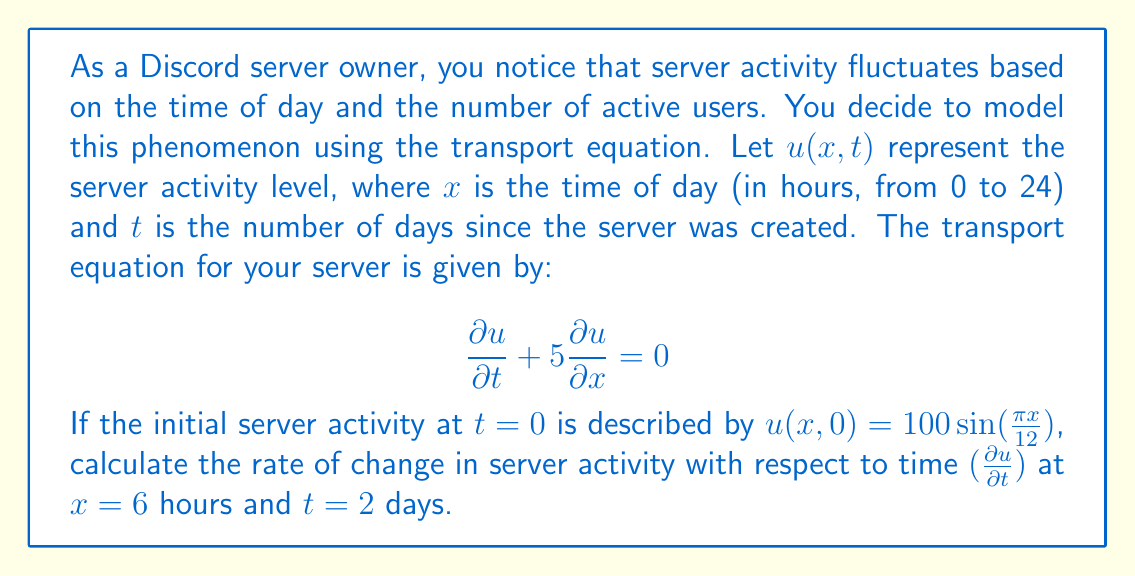Solve this math problem. To solve this problem, we'll follow these steps:

1) The transport equation is given by:
   $$\frac{\partial u}{\partial t} + 5\frac{\partial u}{\partial x} = 0$$

2) We're given the initial condition:
   $$u(x,0) = 100\sin(\frac{\pi x}{12})$$

3) The general solution to the transport equation is:
   $$u(x,t) = f(x - ct)$$
   where $c$ is the wave speed (in this case, $c = 5$), and $f$ is determined by the initial condition.

4) Using the initial condition, we can write:
   $$u(x,t) = 100\sin(\frac{\pi(x - 5t)}{12})$$

5) To find $\frac{\partial u}{\partial t}$, we differentiate with respect to $t$:
   $$\frac{\partial u}{\partial t} = 100 \cdot \frac{\pi}{12} \cdot (-5) \cdot \cos(\frac{\pi(x - 5t)}{12})$$
   $$\frac{\partial u}{\partial t} = -\frac{500\pi}{12} \cos(\frac{\pi(x - 5t)}{12})$$

6) Now, we evaluate this at $x=6$ and $t=2$:
   $$\frac{\partial u}{\partial t}|_{x=6,t=2} = -\frac{500\pi}{12} \cos(\frac{\pi(6 - 5\cdot2)}{12})$$
   $$= -\frac{500\pi}{12} \cos(\frac{\pi(-4)}{12})$$
   $$= -\frac{500\pi}{12} \cos(-\frac{\pi}{3})$$
   $$= -\frac{500\pi}{12} \cdot \frac{1}{2}$$
   $$= -\frac{250\pi}{12}$$
Answer: The rate of change in server activity with respect to time at $x=6$ hours and $t=2$ days is $-\frac{250\pi}{12}$ ≈ -65.45 activity units per day. 